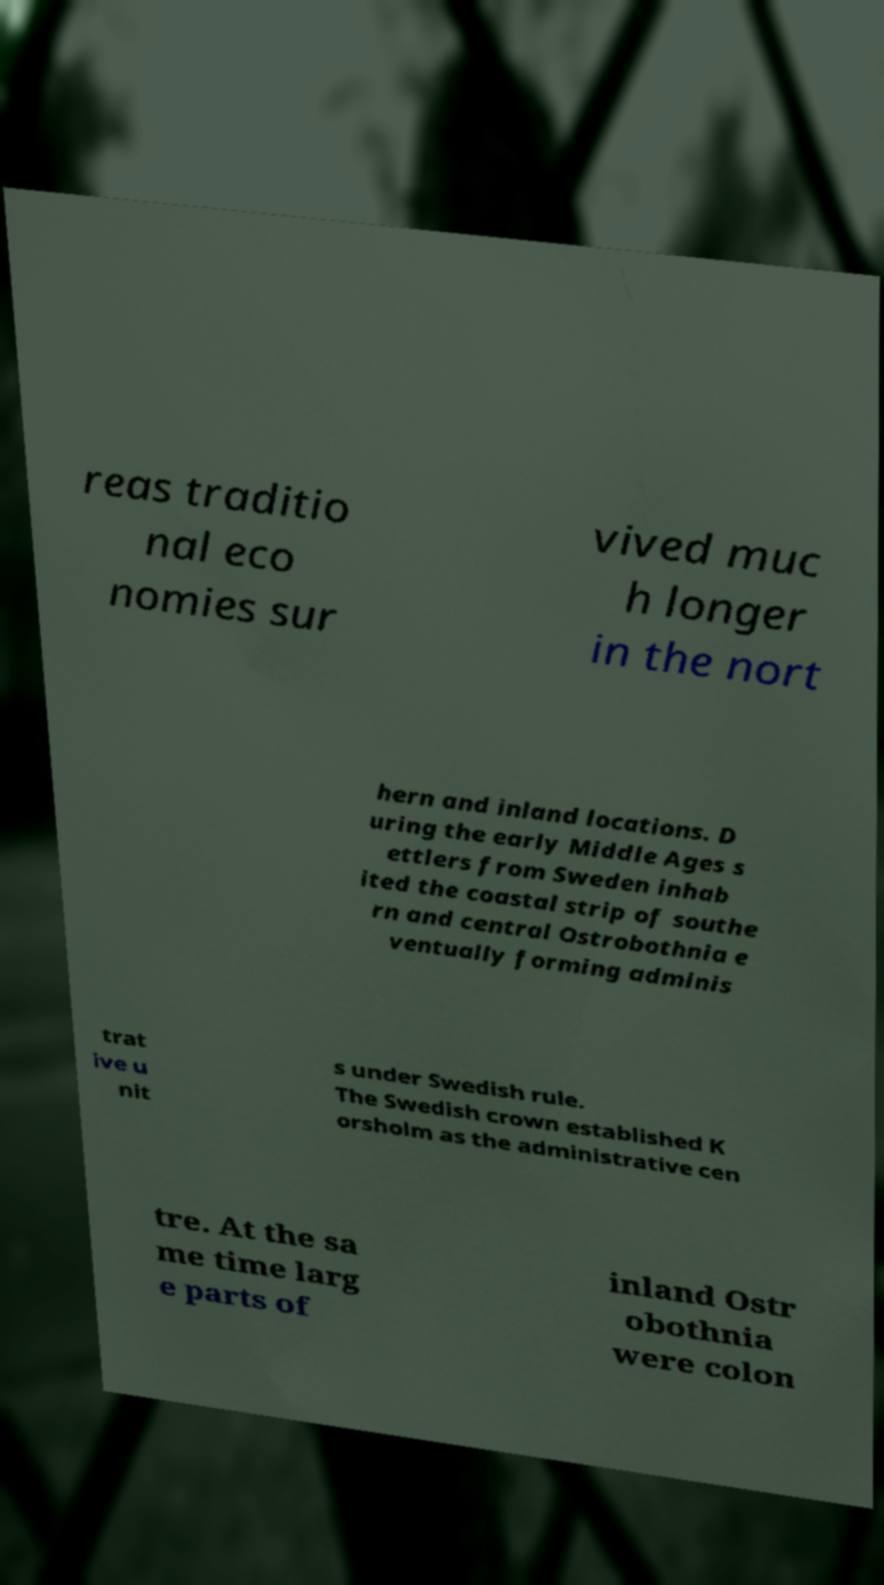Please read and relay the text visible in this image. What does it say? reas traditio nal eco nomies sur vived muc h longer in the nort hern and inland locations. D uring the early Middle Ages s ettlers from Sweden inhab ited the coastal strip of southe rn and central Ostrobothnia e ventually forming adminis trat ive u nit s under Swedish rule. The Swedish crown established K orsholm as the administrative cen tre. At the sa me time larg e parts of inland Ostr obothnia were colon 